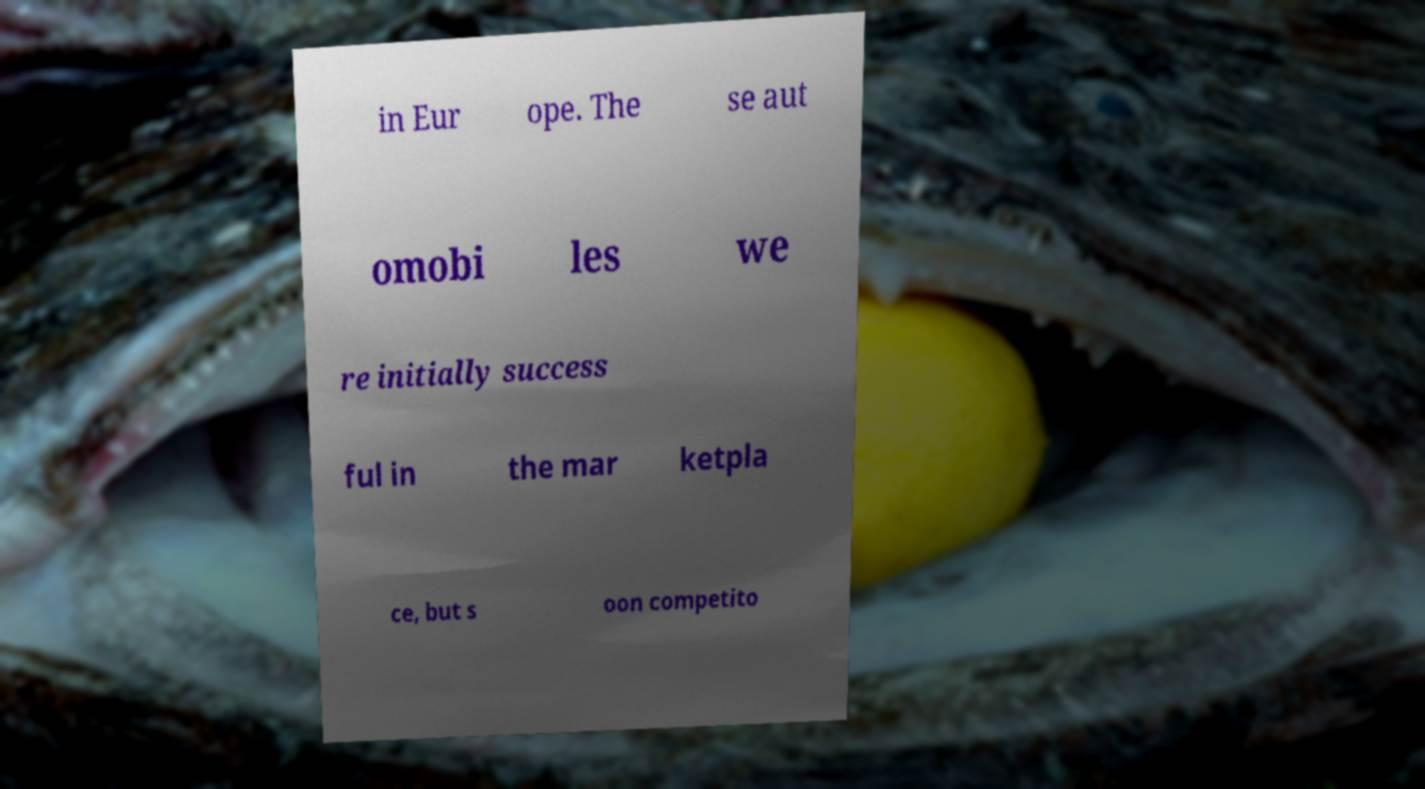Please read and relay the text visible in this image. What does it say? in Eur ope. The se aut omobi les we re initially success ful in the mar ketpla ce, but s oon competito 